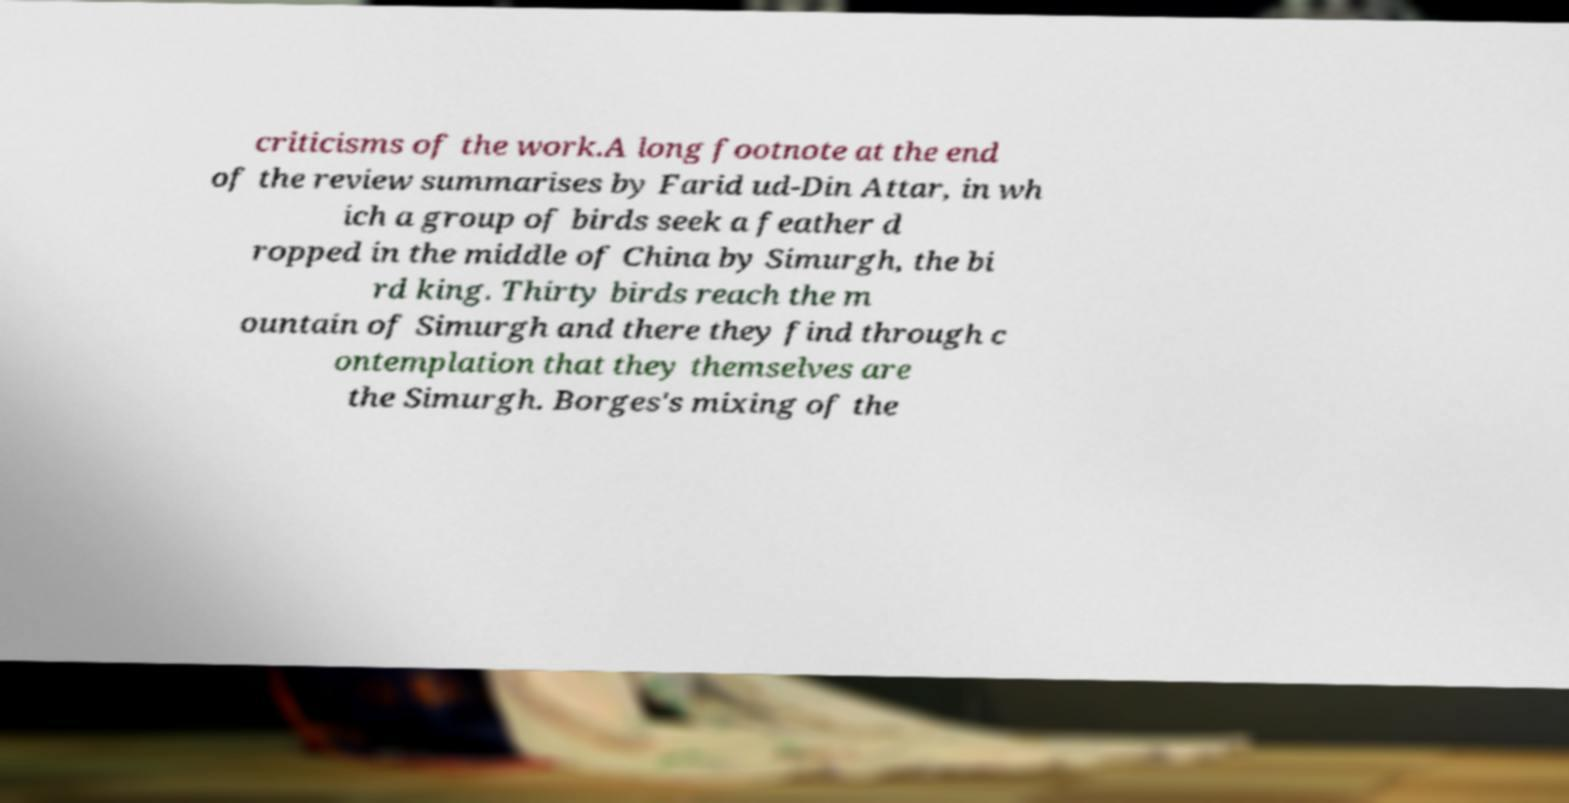What messages or text are displayed in this image? I need them in a readable, typed format. criticisms of the work.A long footnote at the end of the review summarises by Farid ud-Din Attar, in wh ich a group of birds seek a feather d ropped in the middle of China by Simurgh, the bi rd king. Thirty birds reach the m ountain of Simurgh and there they find through c ontemplation that they themselves are the Simurgh. Borges's mixing of the 